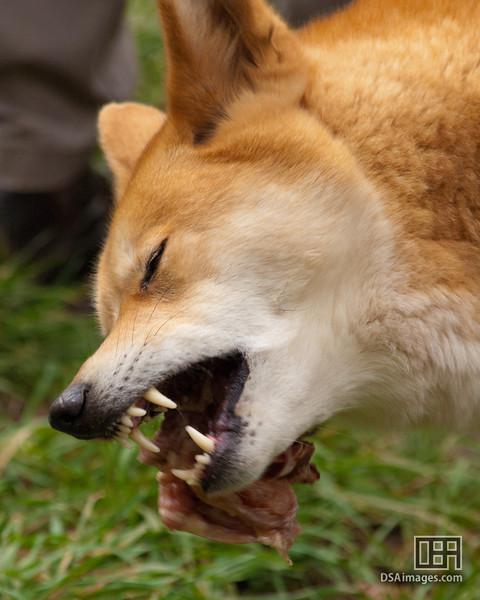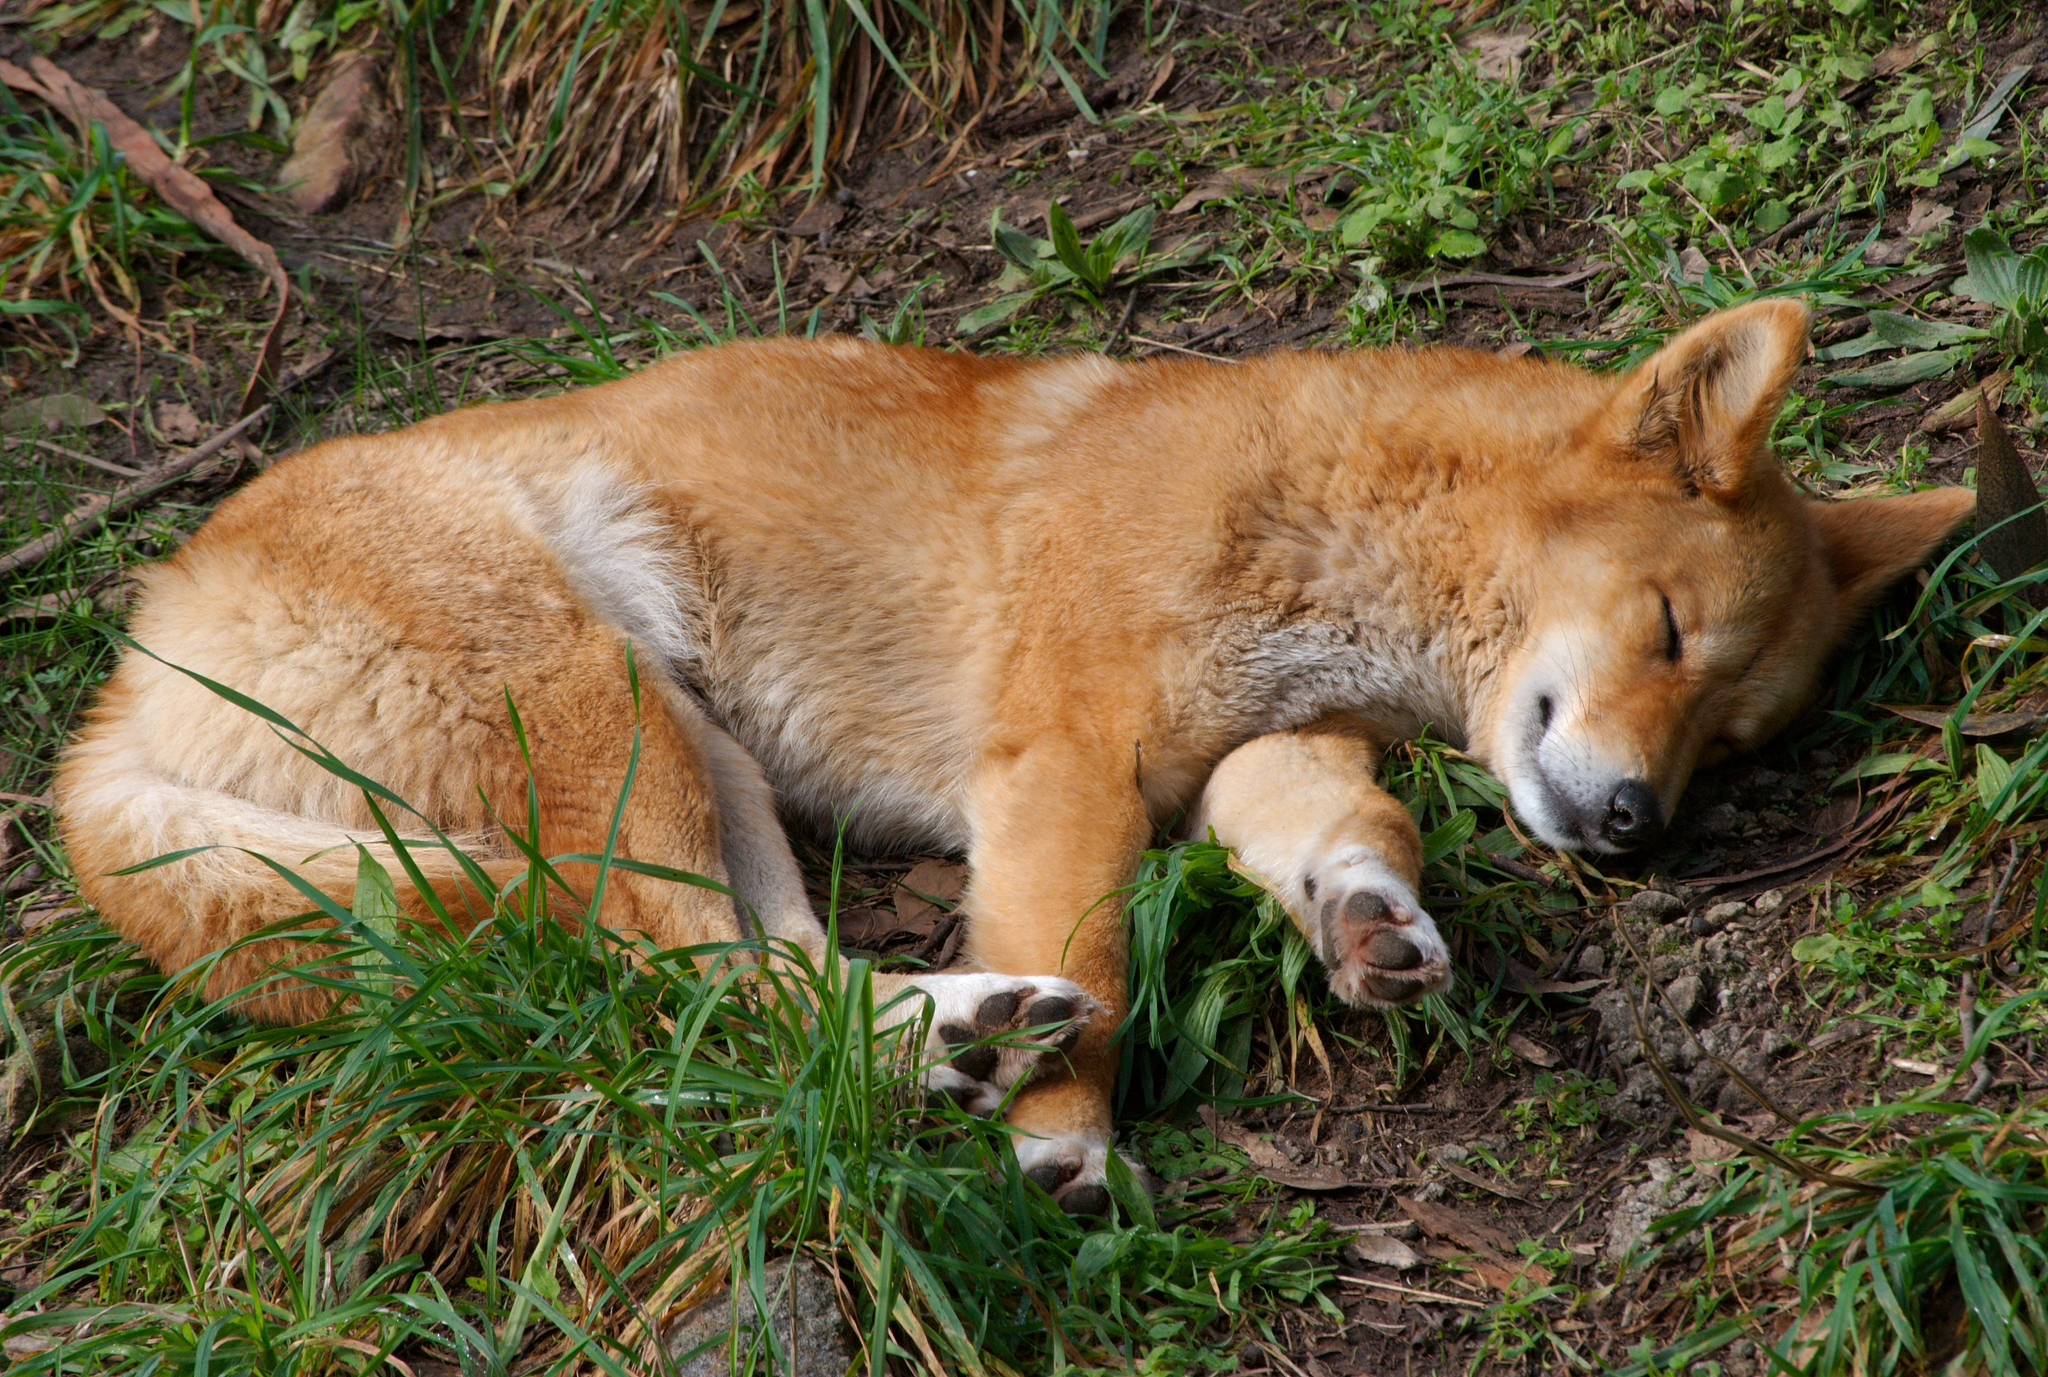The first image is the image on the left, the second image is the image on the right. Examine the images to the left and right. Is the description "There is a tan and white canine laying in the dirt and grass." accurate? Answer yes or no. Yes. The first image is the image on the left, the second image is the image on the right. For the images displayed, is the sentence "The dingo on the right is laying on the grass." factually correct? Answer yes or no. Yes. 